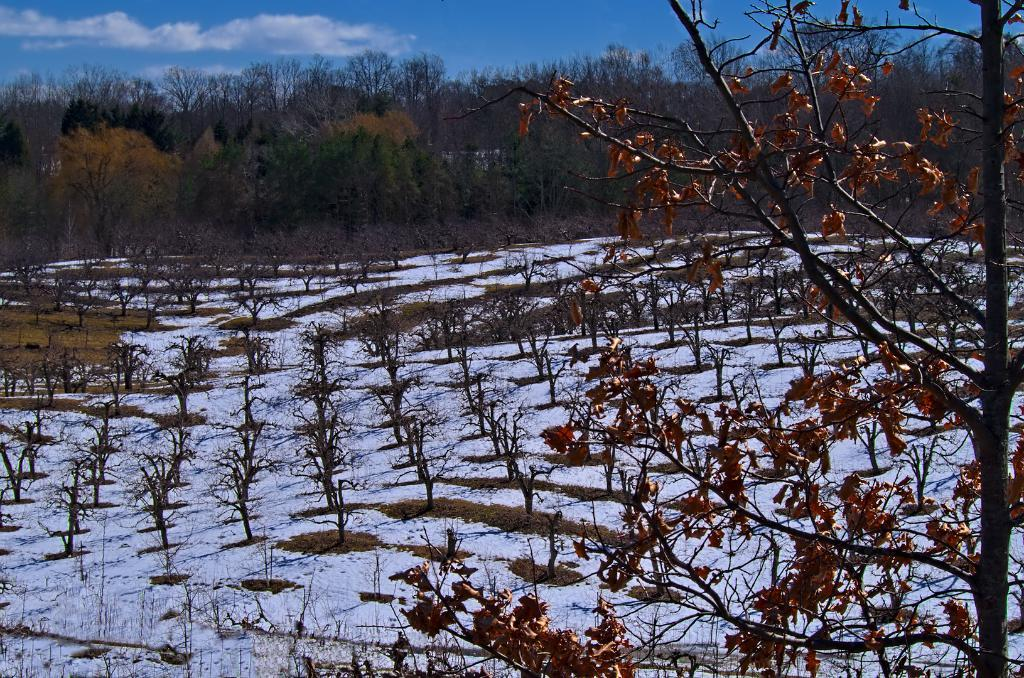What type of vegetation is located at the front of the image? There is a tree in the front of the image. What can be seen in the center of the image? There are plants in the center of the image. What type of vegetation is visible in the background of the image? There are trees in the background of the image. How would you describe the sky in the image? The sky is cloudy in the image. Can you see anyone smashing a drink in the image? There is no reference to a drink or anyone smashing it in the image. Is there anyone smiling in the image? There is no indication of any people or faces in the image, so it is not possible to determine if anyone is smiling. 